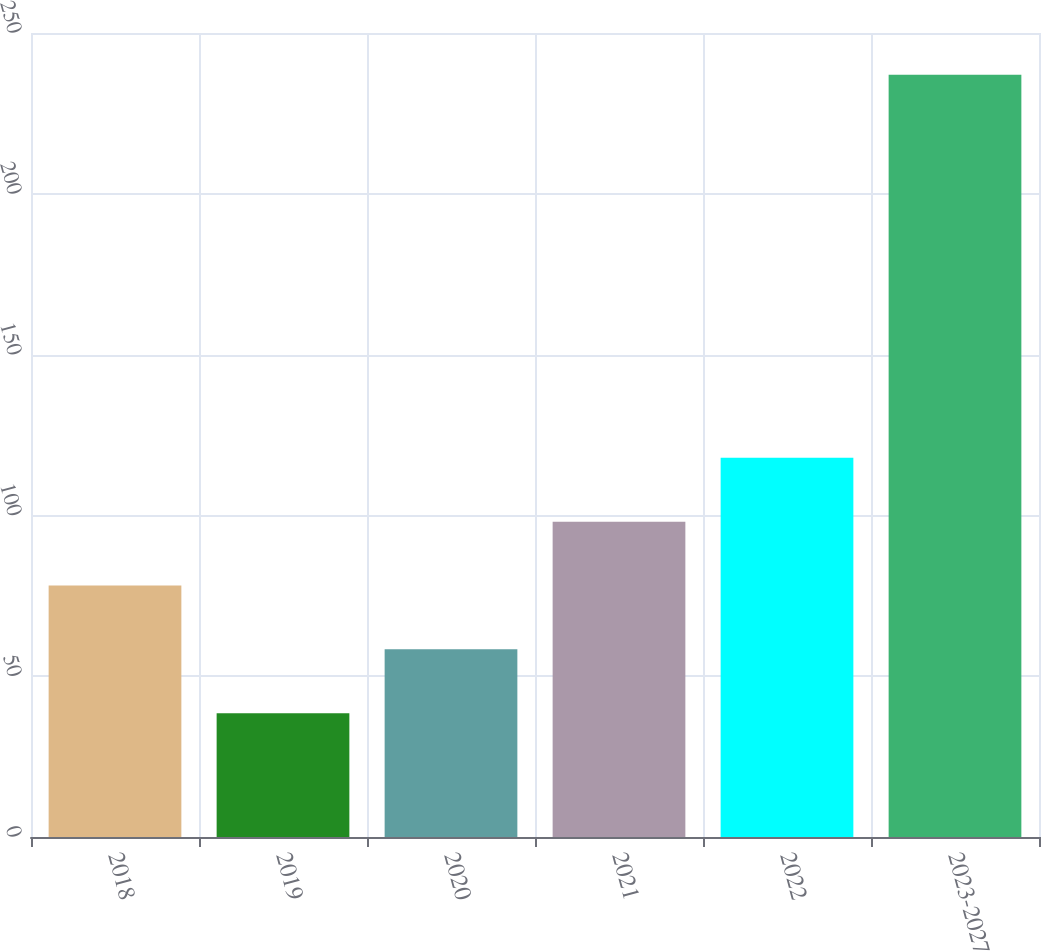Convert chart to OTSL. <chart><loc_0><loc_0><loc_500><loc_500><bar_chart><fcel>2018<fcel>2019<fcel>2020<fcel>2021<fcel>2022<fcel>2023-2027<nl><fcel>78.2<fcel>38.5<fcel>58.35<fcel>98.05<fcel>117.9<fcel>237<nl></chart> 